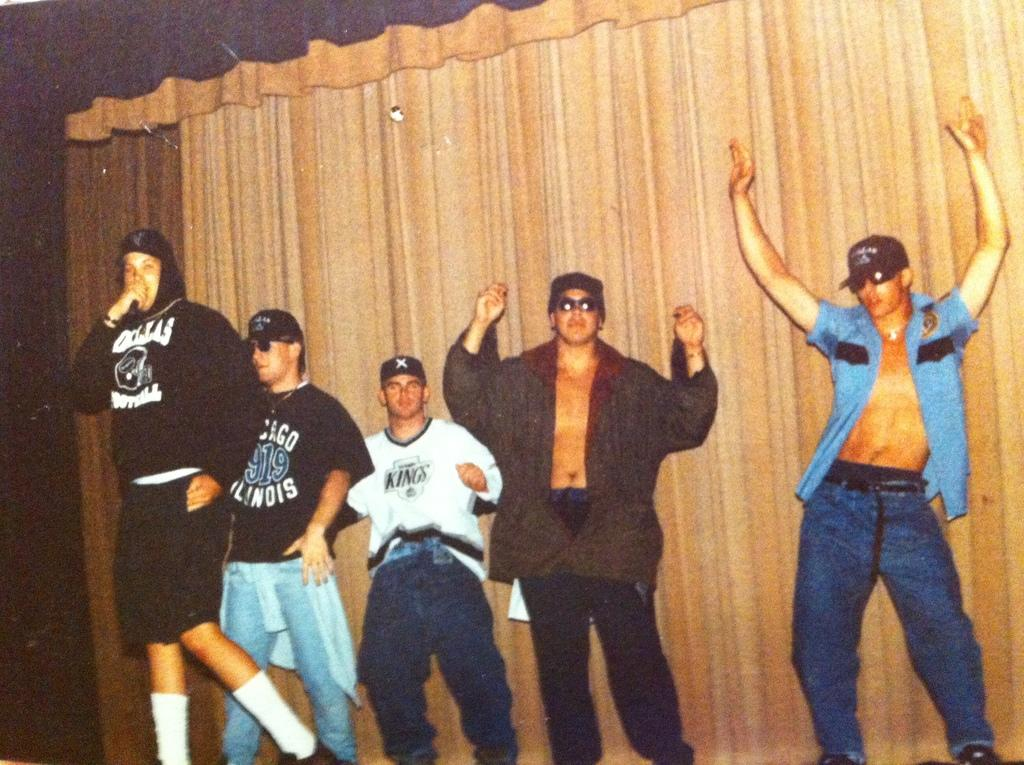Provide a one-sentence caption for the provided image. The man in the white shirt is representing the Kings. 